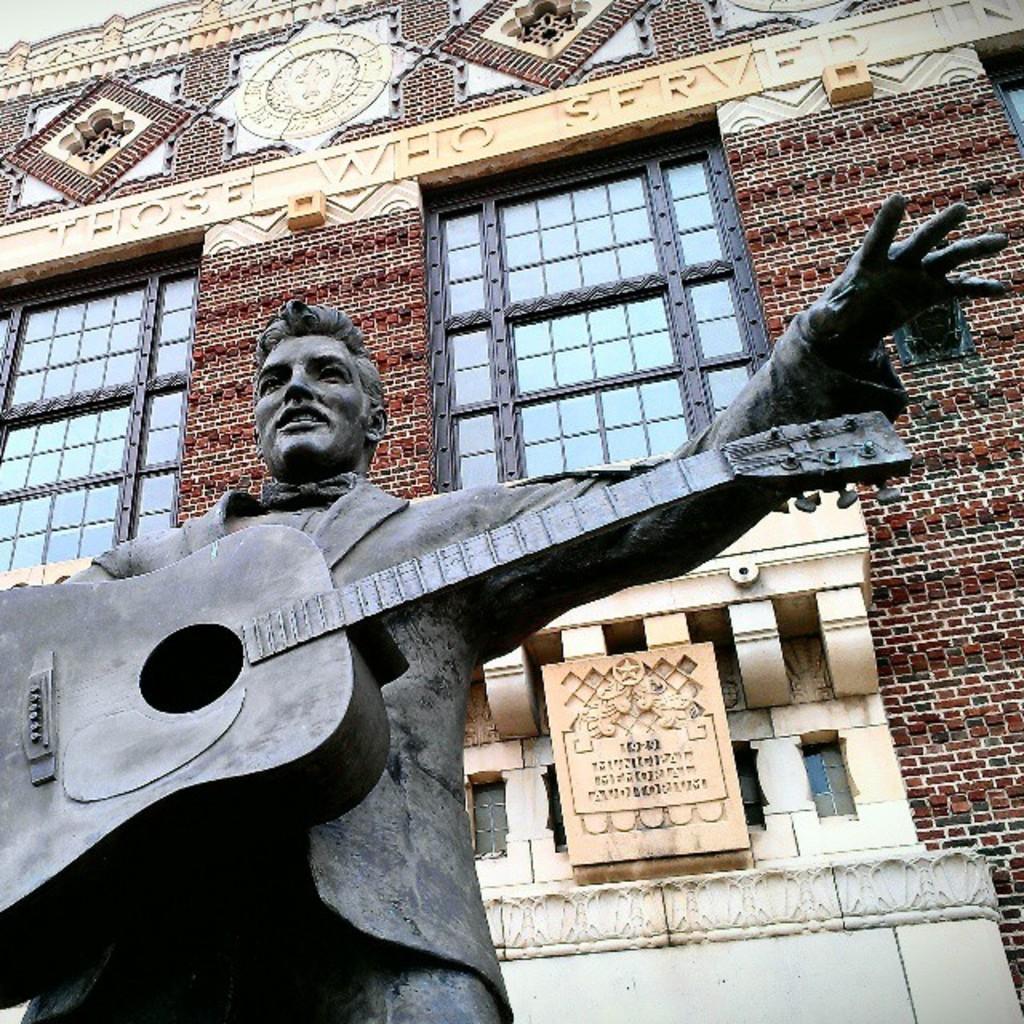How would you summarize this image in a sentence or two? In this picture we can see a statue of man holding guitar in his hands and in background we can see building with windows, beautiful architecture. 